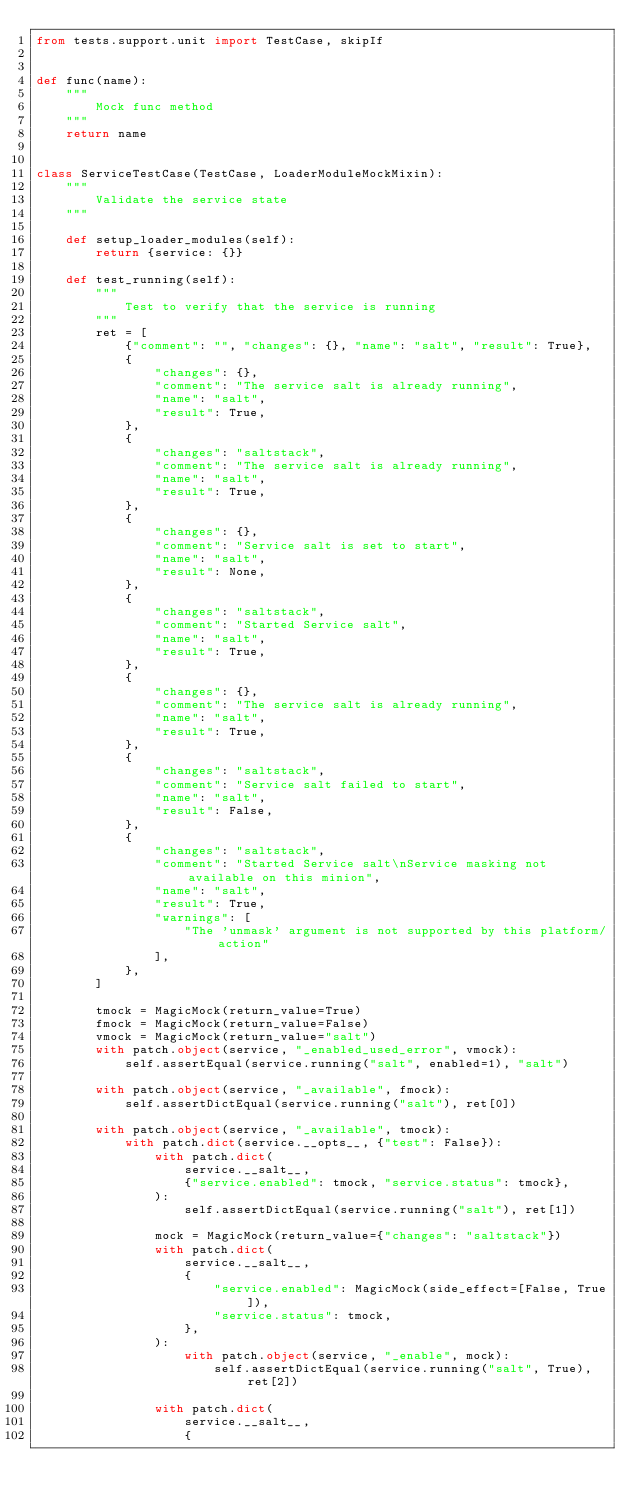Convert code to text. <code><loc_0><loc_0><loc_500><loc_500><_Python_>from tests.support.unit import TestCase, skipIf


def func(name):
    """
        Mock func method
    """
    return name


class ServiceTestCase(TestCase, LoaderModuleMockMixin):
    """
        Validate the service state
    """

    def setup_loader_modules(self):
        return {service: {}}

    def test_running(self):
        """
            Test to verify that the service is running
        """
        ret = [
            {"comment": "", "changes": {}, "name": "salt", "result": True},
            {
                "changes": {},
                "comment": "The service salt is already running",
                "name": "salt",
                "result": True,
            },
            {
                "changes": "saltstack",
                "comment": "The service salt is already running",
                "name": "salt",
                "result": True,
            },
            {
                "changes": {},
                "comment": "Service salt is set to start",
                "name": "salt",
                "result": None,
            },
            {
                "changes": "saltstack",
                "comment": "Started Service salt",
                "name": "salt",
                "result": True,
            },
            {
                "changes": {},
                "comment": "The service salt is already running",
                "name": "salt",
                "result": True,
            },
            {
                "changes": "saltstack",
                "comment": "Service salt failed to start",
                "name": "salt",
                "result": False,
            },
            {
                "changes": "saltstack",
                "comment": "Started Service salt\nService masking not available on this minion",
                "name": "salt",
                "result": True,
                "warnings": [
                    "The 'unmask' argument is not supported by this platform/action"
                ],
            },
        ]

        tmock = MagicMock(return_value=True)
        fmock = MagicMock(return_value=False)
        vmock = MagicMock(return_value="salt")
        with patch.object(service, "_enabled_used_error", vmock):
            self.assertEqual(service.running("salt", enabled=1), "salt")

        with patch.object(service, "_available", fmock):
            self.assertDictEqual(service.running("salt"), ret[0])

        with patch.object(service, "_available", tmock):
            with patch.dict(service.__opts__, {"test": False}):
                with patch.dict(
                    service.__salt__,
                    {"service.enabled": tmock, "service.status": tmock},
                ):
                    self.assertDictEqual(service.running("salt"), ret[1])

                mock = MagicMock(return_value={"changes": "saltstack"})
                with patch.dict(
                    service.__salt__,
                    {
                        "service.enabled": MagicMock(side_effect=[False, True]),
                        "service.status": tmock,
                    },
                ):
                    with patch.object(service, "_enable", mock):
                        self.assertDictEqual(service.running("salt", True), ret[2])

                with patch.dict(
                    service.__salt__,
                    {</code> 